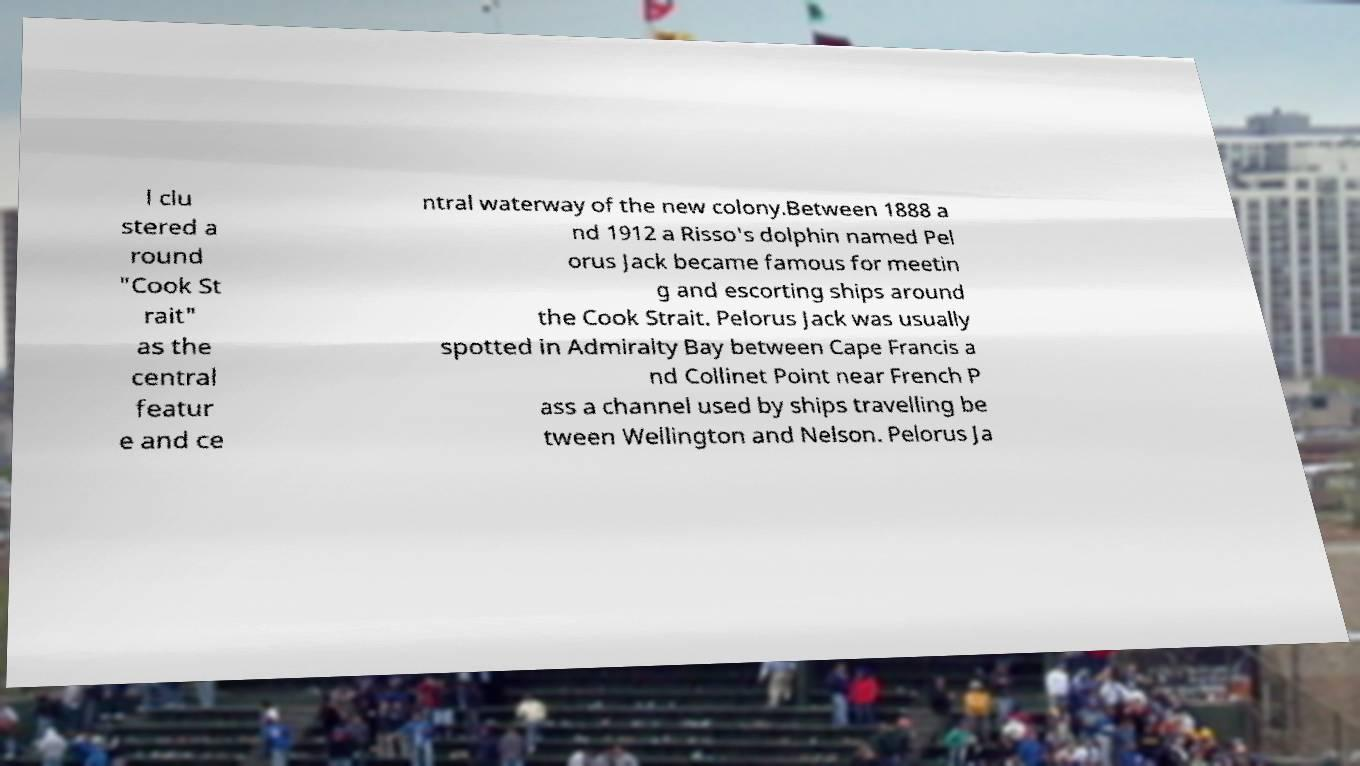I need the written content from this picture converted into text. Can you do that? l clu stered a round "Cook St rait" as the central featur e and ce ntral waterway of the new colony.Between 1888 a nd 1912 a Risso's dolphin named Pel orus Jack became famous for meetin g and escorting ships around the Cook Strait. Pelorus Jack was usually spotted in Admiralty Bay between Cape Francis a nd Collinet Point near French P ass a channel used by ships travelling be tween Wellington and Nelson. Pelorus Ja 